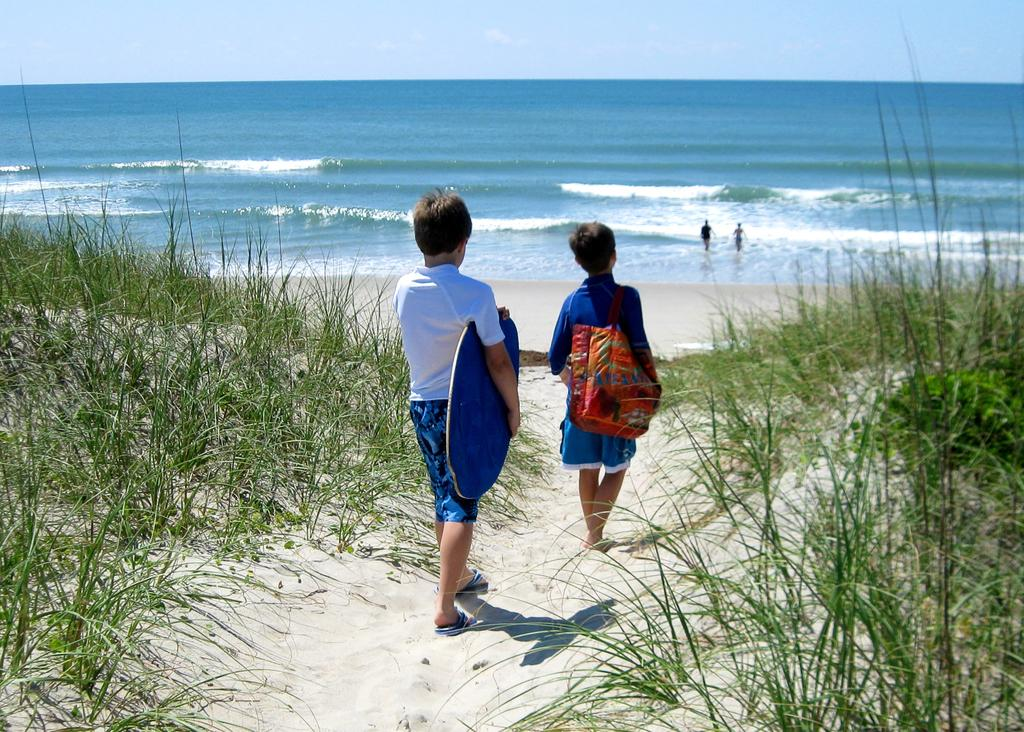What are the two boys in the image doing? The two boys in the image are walking towards the beach. What type of terrain can be seen on the right side of the image? There is sand and grass on the right side of the image. What is visible in the background of the image? There is a sea, two people, waves, and the sky visible in the background of the image. What type of brass instrument is the uncle playing in the image? There is no uncle or brass instrument present in the image. How does the sea shake in the image? The sea does not shake in the image; it is a static background element. 